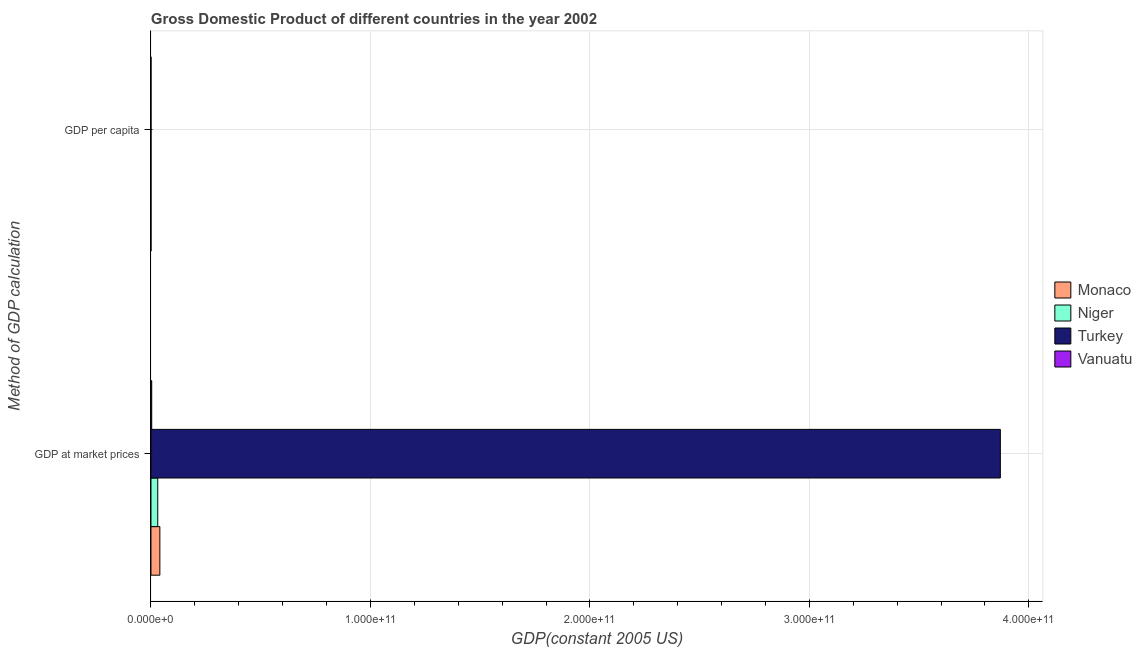Are the number of bars per tick equal to the number of legend labels?
Provide a succinct answer. Yes. Are the number of bars on each tick of the Y-axis equal?
Keep it short and to the point. Yes. What is the label of the 2nd group of bars from the top?
Your answer should be compact. GDP at market prices. What is the gdp per capita in Monaco?
Ensure brevity in your answer.  1.24e+05. Across all countries, what is the maximum gdp at market prices?
Your answer should be compact. 3.87e+11. Across all countries, what is the minimum gdp per capita?
Ensure brevity in your answer.  256. In which country was the gdp per capita maximum?
Ensure brevity in your answer.  Monaco. In which country was the gdp per capita minimum?
Your answer should be very brief. Niger. What is the total gdp at market prices in the graph?
Offer a very short reply. 3.95e+11. What is the difference between the gdp per capita in Monaco and that in Vanuatu?
Make the answer very short. 1.22e+05. What is the difference between the gdp at market prices in Monaco and the gdp per capita in Vanuatu?
Ensure brevity in your answer.  4.06e+09. What is the average gdp per capita per country?
Your answer should be compact. 3.30e+04. What is the difference between the gdp per capita and gdp at market prices in Niger?
Your response must be concise. -3.09e+09. What is the ratio of the gdp at market prices in Vanuatu to that in Niger?
Your answer should be compact. 0.11. What does the 1st bar from the top in GDP per capita represents?
Provide a succinct answer. Vanuatu. What does the 1st bar from the bottom in GDP at market prices represents?
Provide a short and direct response. Monaco. Are all the bars in the graph horizontal?
Make the answer very short. Yes. What is the difference between two consecutive major ticks on the X-axis?
Your answer should be very brief. 1.00e+11. Where does the legend appear in the graph?
Your answer should be compact. Center right. How are the legend labels stacked?
Ensure brevity in your answer.  Vertical. What is the title of the graph?
Give a very brief answer. Gross Domestic Product of different countries in the year 2002. Does "Somalia" appear as one of the legend labels in the graph?
Offer a very short reply. No. What is the label or title of the X-axis?
Make the answer very short. GDP(constant 2005 US). What is the label or title of the Y-axis?
Your response must be concise. Method of GDP calculation. What is the GDP(constant 2005 US) of Monaco in GDP at market prices?
Provide a short and direct response. 4.06e+09. What is the GDP(constant 2005 US) in Niger in GDP at market prices?
Provide a short and direct response. 3.09e+09. What is the GDP(constant 2005 US) in Turkey in GDP at market prices?
Give a very brief answer. 3.87e+11. What is the GDP(constant 2005 US) of Vanuatu in GDP at market prices?
Give a very brief answer. 3.46e+08. What is the GDP(constant 2005 US) of Monaco in GDP per capita?
Provide a short and direct response. 1.24e+05. What is the GDP(constant 2005 US) of Niger in GDP per capita?
Your answer should be compact. 256. What is the GDP(constant 2005 US) of Turkey in GDP per capita?
Keep it short and to the point. 5942.73. What is the GDP(constant 2005 US) in Vanuatu in GDP per capita?
Give a very brief answer. 1783.13. Across all Method of GDP calculation, what is the maximum GDP(constant 2005 US) of Monaco?
Make the answer very short. 4.06e+09. Across all Method of GDP calculation, what is the maximum GDP(constant 2005 US) of Niger?
Give a very brief answer. 3.09e+09. Across all Method of GDP calculation, what is the maximum GDP(constant 2005 US) in Turkey?
Give a very brief answer. 3.87e+11. Across all Method of GDP calculation, what is the maximum GDP(constant 2005 US) of Vanuatu?
Provide a succinct answer. 3.46e+08. Across all Method of GDP calculation, what is the minimum GDP(constant 2005 US) in Monaco?
Offer a terse response. 1.24e+05. Across all Method of GDP calculation, what is the minimum GDP(constant 2005 US) of Niger?
Provide a succinct answer. 256. Across all Method of GDP calculation, what is the minimum GDP(constant 2005 US) in Turkey?
Provide a short and direct response. 5942.73. Across all Method of GDP calculation, what is the minimum GDP(constant 2005 US) in Vanuatu?
Ensure brevity in your answer.  1783.13. What is the total GDP(constant 2005 US) of Monaco in the graph?
Give a very brief answer. 4.06e+09. What is the total GDP(constant 2005 US) in Niger in the graph?
Provide a short and direct response. 3.09e+09. What is the total GDP(constant 2005 US) of Turkey in the graph?
Make the answer very short. 3.87e+11. What is the total GDP(constant 2005 US) in Vanuatu in the graph?
Provide a short and direct response. 3.46e+08. What is the difference between the GDP(constant 2005 US) of Monaco in GDP at market prices and that in GDP per capita?
Your response must be concise. 4.05e+09. What is the difference between the GDP(constant 2005 US) in Niger in GDP at market prices and that in GDP per capita?
Keep it short and to the point. 3.09e+09. What is the difference between the GDP(constant 2005 US) of Turkey in GDP at market prices and that in GDP per capita?
Your answer should be compact. 3.87e+11. What is the difference between the GDP(constant 2005 US) of Vanuatu in GDP at market prices and that in GDP per capita?
Provide a short and direct response. 3.46e+08. What is the difference between the GDP(constant 2005 US) of Monaco in GDP at market prices and the GDP(constant 2005 US) of Niger in GDP per capita?
Give a very brief answer. 4.06e+09. What is the difference between the GDP(constant 2005 US) in Monaco in GDP at market prices and the GDP(constant 2005 US) in Turkey in GDP per capita?
Ensure brevity in your answer.  4.06e+09. What is the difference between the GDP(constant 2005 US) in Monaco in GDP at market prices and the GDP(constant 2005 US) in Vanuatu in GDP per capita?
Ensure brevity in your answer.  4.06e+09. What is the difference between the GDP(constant 2005 US) in Niger in GDP at market prices and the GDP(constant 2005 US) in Turkey in GDP per capita?
Give a very brief answer. 3.09e+09. What is the difference between the GDP(constant 2005 US) in Niger in GDP at market prices and the GDP(constant 2005 US) in Vanuatu in GDP per capita?
Give a very brief answer. 3.09e+09. What is the difference between the GDP(constant 2005 US) of Turkey in GDP at market prices and the GDP(constant 2005 US) of Vanuatu in GDP per capita?
Provide a short and direct response. 3.87e+11. What is the average GDP(constant 2005 US) of Monaco per Method of GDP calculation?
Offer a terse response. 2.03e+09. What is the average GDP(constant 2005 US) of Niger per Method of GDP calculation?
Your response must be concise. 1.55e+09. What is the average GDP(constant 2005 US) of Turkey per Method of GDP calculation?
Give a very brief answer. 1.94e+11. What is the average GDP(constant 2005 US) of Vanuatu per Method of GDP calculation?
Your answer should be compact. 1.73e+08. What is the difference between the GDP(constant 2005 US) of Monaco and GDP(constant 2005 US) of Niger in GDP at market prices?
Ensure brevity in your answer.  9.64e+08. What is the difference between the GDP(constant 2005 US) of Monaco and GDP(constant 2005 US) of Turkey in GDP at market prices?
Your response must be concise. -3.83e+11. What is the difference between the GDP(constant 2005 US) in Monaco and GDP(constant 2005 US) in Vanuatu in GDP at market prices?
Your answer should be compact. 3.71e+09. What is the difference between the GDP(constant 2005 US) in Niger and GDP(constant 2005 US) in Turkey in GDP at market prices?
Make the answer very short. -3.84e+11. What is the difference between the GDP(constant 2005 US) in Niger and GDP(constant 2005 US) in Vanuatu in GDP at market prices?
Give a very brief answer. 2.75e+09. What is the difference between the GDP(constant 2005 US) of Turkey and GDP(constant 2005 US) of Vanuatu in GDP at market prices?
Your answer should be very brief. 3.87e+11. What is the difference between the GDP(constant 2005 US) in Monaco and GDP(constant 2005 US) in Niger in GDP per capita?
Your answer should be compact. 1.24e+05. What is the difference between the GDP(constant 2005 US) in Monaco and GDP(constant 2005 US) in Turkey in GDP per capita?
Give a very brief answer. 1.18e+05. What is the difference between the GDP(constant 2005 US) of Monaco and GDP(constant 2005 US) of Vanuatu in GDP per capita?
Your answer should be very brief. 1.22e+05. What is the difference between the GDP(constant 2005 US) in Niger and GDP(constant 2005 US) in Turkey in GDP per capita?
Make the answer very short. -5686.73. What is the difference between the GDP(constant 2005 US) in Niger and GDP(constant 2005 US) in Vanuatu in GDP per capita?
Keep it short and to the point. -1527.14. What is the difference between the GDP(constant 2005 US) in Turkey and GDP(constant 2005 US) in Vanuatu in GDP per capita?
Your answer should be compact. 4159.59. What is the ratio of the GDP(constant 2005 US) in Monaco in GDP at market prices to that in GDP per capita?
Give a very brief answer. 3.26e+04. What is the ratio of the GDP(constant 2005 US) in Niger in GDP at market prices to that in GDP per capita?
Your answer should be compact. 1.21e+07. What is the ratio of the GDP(constant 2005 US) of Turkey in GDP at market prices to that in GDP per capita?
Offer a terse response. 6.51e+07. What is the ratio of the GDP(constant 2005 US) in Vanuatu in GDP at market prices to that in GDP per capita?
Provide a short and direct response. 1.94e+05. What is the difference between the highest and the second highest GDP(constant 2005 US) of Monaco?
Make the answer very short. 4.05e+09. What is the difference between the highest and the second highest GDP(constant 2005 US) in Niger?
Give a very brief answer. 3.09e+09. What is the difference between the highest and the second highest GDP(constant 2005 US) of Turkey?
Offer a terse response. 3.87e+11. What is the difference between the highest and the second highest GDP(constant 2005 US) in Vanuatu?
Your response must be concise. 3.46e+08. What is the difference between the highest and the lowest GDP(constant 2005 US) of Monaco?
Provide a succinct answer. 4.05e+09. What is the difference between the highest and the lowest GDP(constant 2005 US) in Niger?
Offer a terse response. 3.09e+09. What is the difference between the highest and the lowest GDP(constant 2005 US) of Turkey?
Offer a very short reply. 3.87e+11. What is the difference between the highest and the lowest GDP(constant 2005 US) of Vanuatu?
Provide a short and direct response. 3.46e+08. 